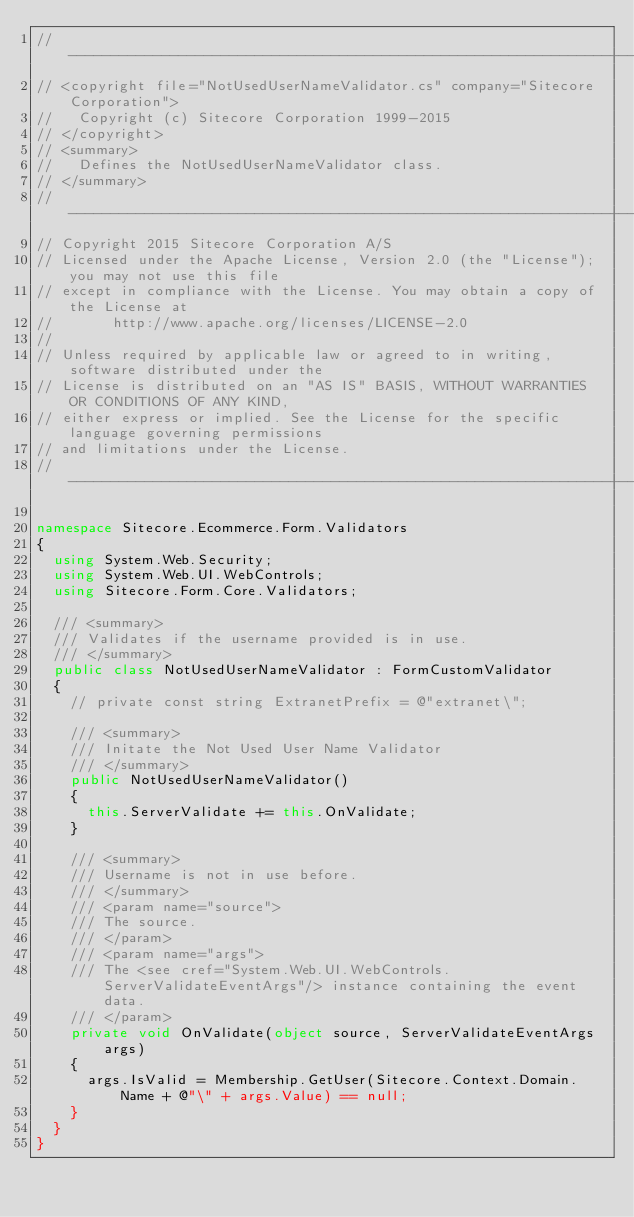<code> <loc_0><loc_0><loc_500><loc_500><_C#_>// --------------------------------------------------------------------------------------------------------------------
// <copyright file="NotUsedUserNameValidator.cs" company="Sitecore Corporation">
//   Copyright (c) Sitecore Corporation 1999-2015
// </copyright>
// <summary>
//   Defines the NotUsedUserNameValidator class.
// </summary>
// --------------------------------------------------------------------------------------------------------------------
// Copyright 2015 Sitecore Corporation A/S
// Licensed under the Apache License, Version 2.0 (the "License"); you may not use this file 
// except in compliance with the License. You may obtain a copy of the License at
//       http://www.apache.org/licenses/LICENSE-2.0
//
// Unless required by applicable law or agreed to in writing, software distributed under the 
// License is distributed on an "AS IS" BASIS, WITHOUT WARRANTIES OR CONDITIONS OF ANY KIND, 
// either express or implied. See the License for the specific language governing permissions 
// and limitations under the License.
// -------------------------------------------------------------------------------------------

namespace Sitecore.Ecommerce.Form.Validators
{
  using System.Web.Security;
  using System.Web.UI.WebControls;
  using Sitecore.Form.Core.Validators;

  /// <summary>
  /// Validates if the username provided is in use.
  /// </summary>
  public class NotUsedUserNameValidator : FormCustomValidator
  {
    // private const string ExtranetPrefix = @"extranet\";

    /// <summary>
    /// Initate the Not Used User Name Validator
    /// </summary>
    public NotUsedUserNameValidator()
    {
      this.ServerValidate += this.OnValidate;
    }

    /// <summary>
    /// Username is not in use before.
    /// </summary>
    /// <param name="source">
    /// The source.
    /// </param>
    /// <param name="args">
    /// The <see cref="System.Web.UI.WebControls.ServerValidateEventArgs"/> instance containing the event data.
    /// </param>
    private void OnValidate(object source, ServerValidateEventArgs args)
    {
      args.IsValid = Membership.GetUser(Sitecore.Context.Domain.Name + @"\" + args.Value) == null;
    }
  }
}</code> 